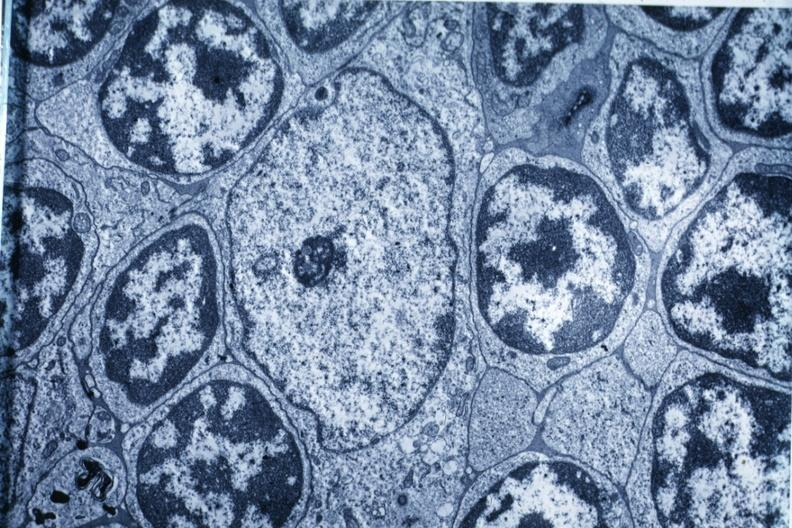s thymoma present?
Answer the question using a single word or phrase. Yes 